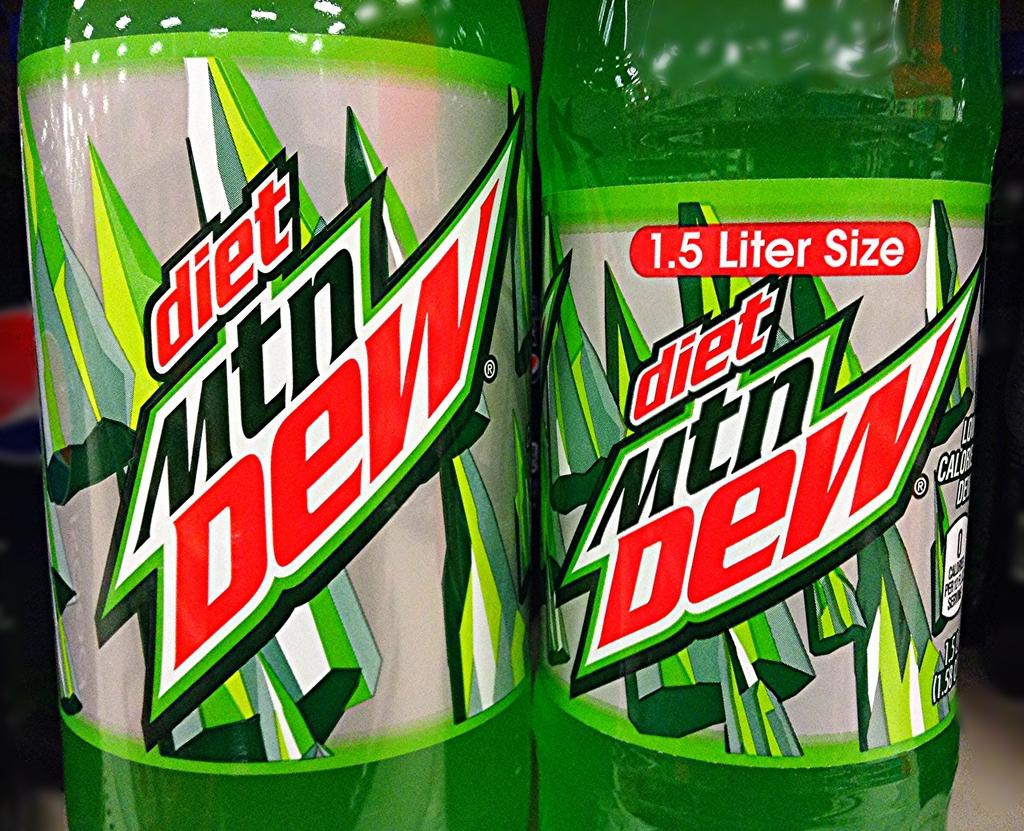<image>
Present a compact description of the photo's key features. Two bottles of diet Mtn Dew placed very closely together 